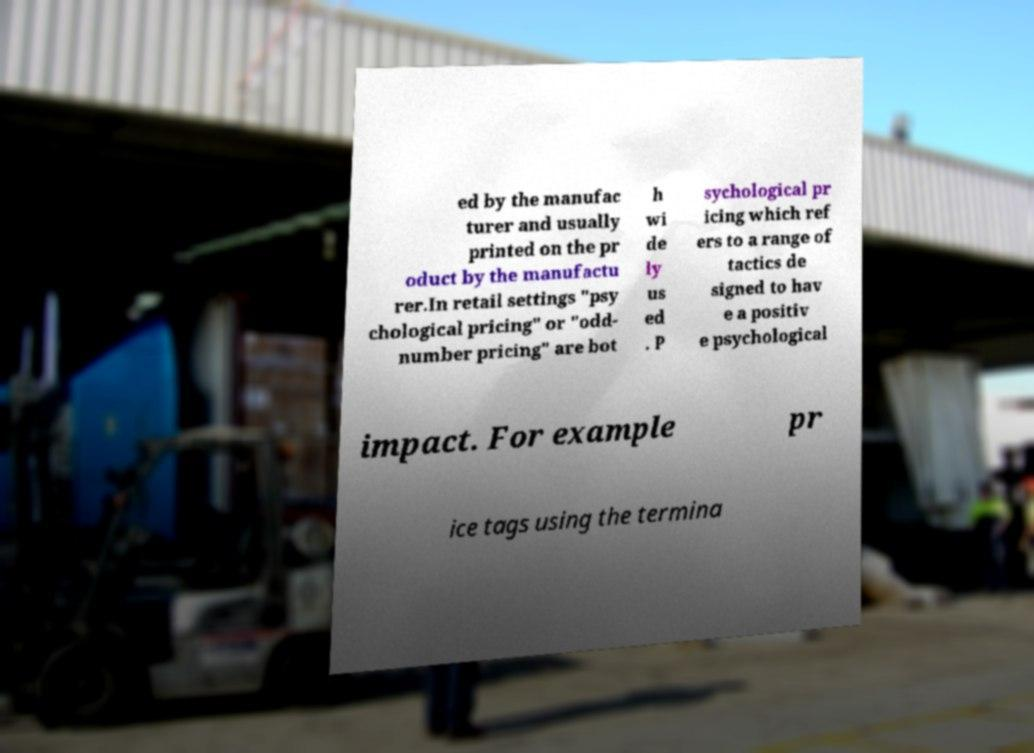Could you assist in decoding the text presented in this image and type it out clearly? ed by the manufac turer and usually printed on the pr oduct by the manufactu rer.In retail settings "psy chological pricing" or "odd- number pricing" are bot h wi de ly us ed . P sychological pr icing which ref ers to a range of tactics de signed to hav e a positiv e psychological impact. For example pr ice tags using the termina 